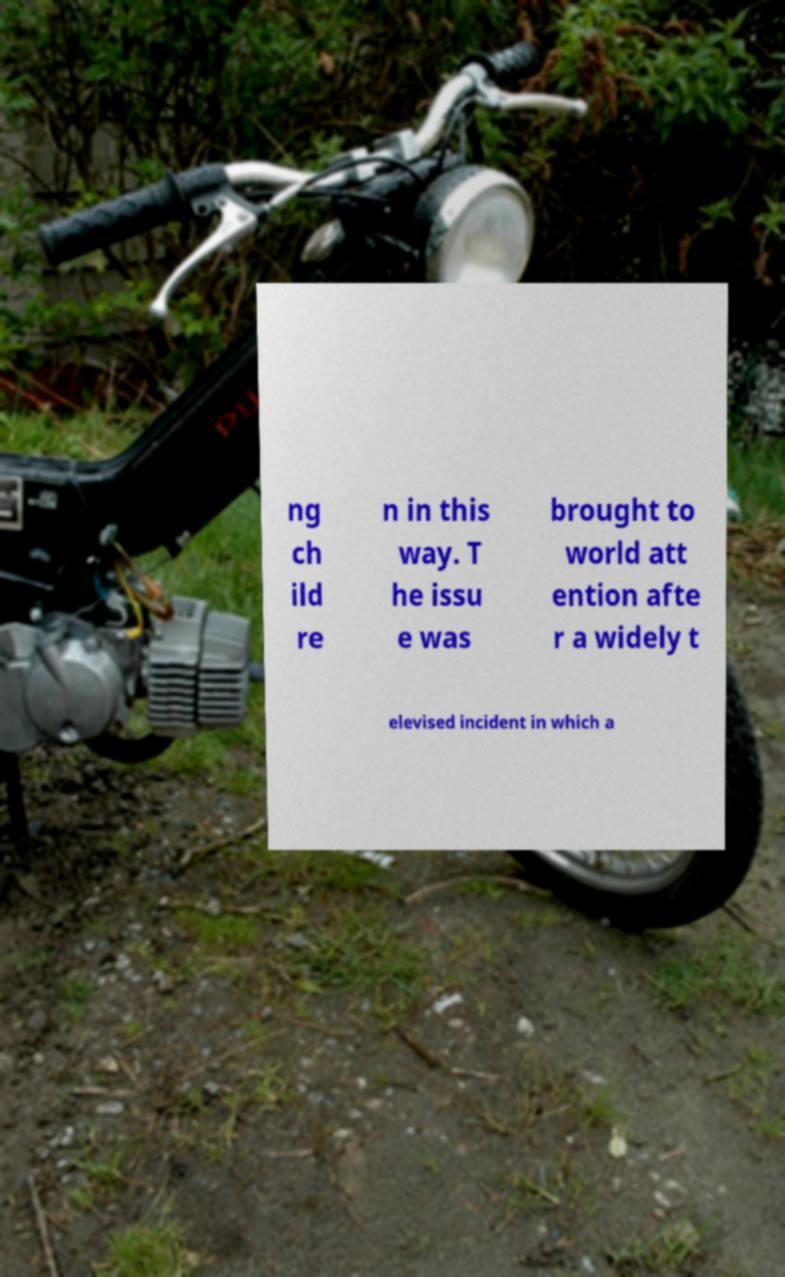Could you assist in decoding the text presented in this image and type it out clearly? ng ch ild re n in this way. T he issu e was brought to world att ention afte r a widely t elevised incident in which a 